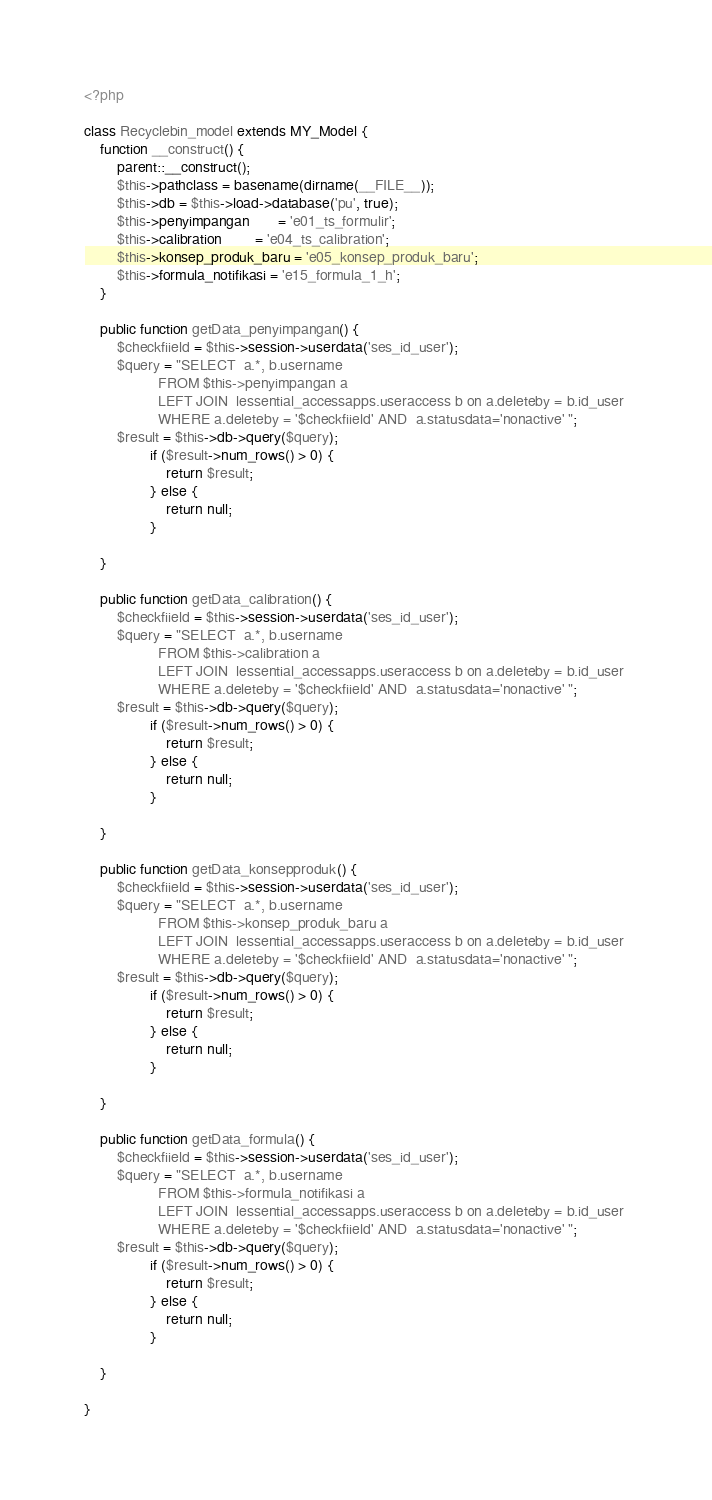<code> <loc_0><loc_0><loc_500><loc_500><_PHP_><?php

class Recyclebin_model extends MY_Model {
    function __construct() {
        parent::__construct();
        $this->pathclass = basename(dirname(__FILE__));
        $this->db = $this->load->database('pu', true);
        $this->penyimpangan       = 'e01_ts_formulir';
        $this->calibration        = 'e04_ts_calibration';
        $this->konsep_produk_baru = 'e05_konsep_produk_baru';
        $this->formula_notifikasi = 'e15_formula_1_h';
    }

    public function getData_penyimpangan() {
        $checkfiield = $this->session->userdata('ses_id_user');
        $query = "SELECT  a.*, b.username
                  FROM $this->penyimpangan a
                  LEFT JOIN  lessential_accessapps.useraccess b on a.deleteby = b.id_user 
                  WHERE a.deleteby = '$checkfiield' AND  a.statusdata='nonactive' ";
        $result = $this->db->query($query);
                if ($result->num_rows() > 0) {
                    return $result;
                } else {
                    return null;
                }
     
    }

    public function getData_calibration() {
        $checkfiield = $this->session->userdata('ses_id_user');
        $query = "SELECT  a.*, b.username
                  FROM $this->calibration a
                  LEFT JOIN  lessential_accessapps.useraccess b on a.deleteby = b.id_user 
                  WHERE a.deleteby = '$checkfiield' AND  a.statusdata='nonactive' ";
        $result = $this->db->query($query);
                if ($result->num_rows() > 0) {
                    return $result;
                } else {
                    return null;
                }
     
    }

    public function getData_konsepproduk() {
        $checkfiield = $this->session->userdata('ses_id_user');
        $query = "SELECT  a.*, b.username
                  FROM $this->konsep_produk_baru a
                  LEFT JOIN  lessential_accessapps.useraccess b on a.deleteby = b.id_user 
                  WHERE a.deleteby = '$checkfiield' AND  a.statusdata='nonactive' ";
        $result = $this->db->query($query);
                if ($result->num_rows() > 0) {
                    return $result;
                } else {
                    return null;
                }
     
    }

    public function getData_formula() {
        $checkfiield = $this->session->userdata('ses_id_user');
        $query = "SELECT  a.*, b.username
                  FROM $this->formula_notifikasi a
                  LEFT JOIN  lessential_accessapps.useraccess b on a.deleteby = b.id_user 
                  WHERE a.deleteby = '$checkfiield' AND  a.statusdata='nonactive' ";
        $result = $this->db->query($query);
                if ($result->num_rows() > 0) {
                    return $result;
                } else {
                    return null;
                }
     
    }

}
</code> 